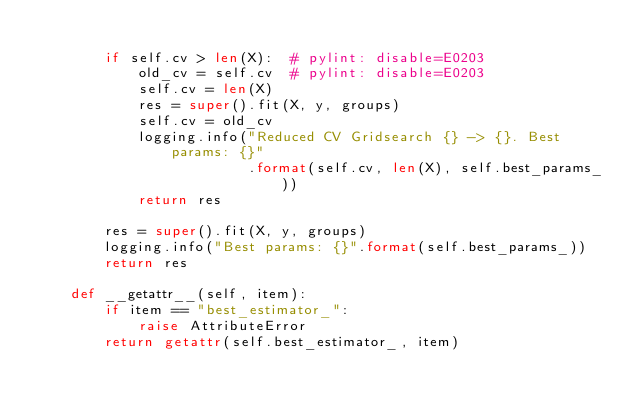<code> <loc_0><loc_0><loc_500><loc_500><_Python_>
        if self.cv > len(X):  # pylint: disable=E0203
            old_cv = self.cv  # pylint: disable=E0203
            self.cv = len(X)
            res = super().fit(X, y, groups)
            self.cv = old_cv
            logging.info("Reduced CV Gridsearch {} -> {}. Best params: {}"
                         .format(self.cv, len(X), self.best_params_))
            return res

        res = super().fit(X, y, groups)
        logging.info("Best params: {}".format(self.best_params_))
        return res

    def __getattr__(self, item):
        if item == "best_estimator_":
            raise AttributeError
        return getattr(self.best_estimator_, item)
</code> 